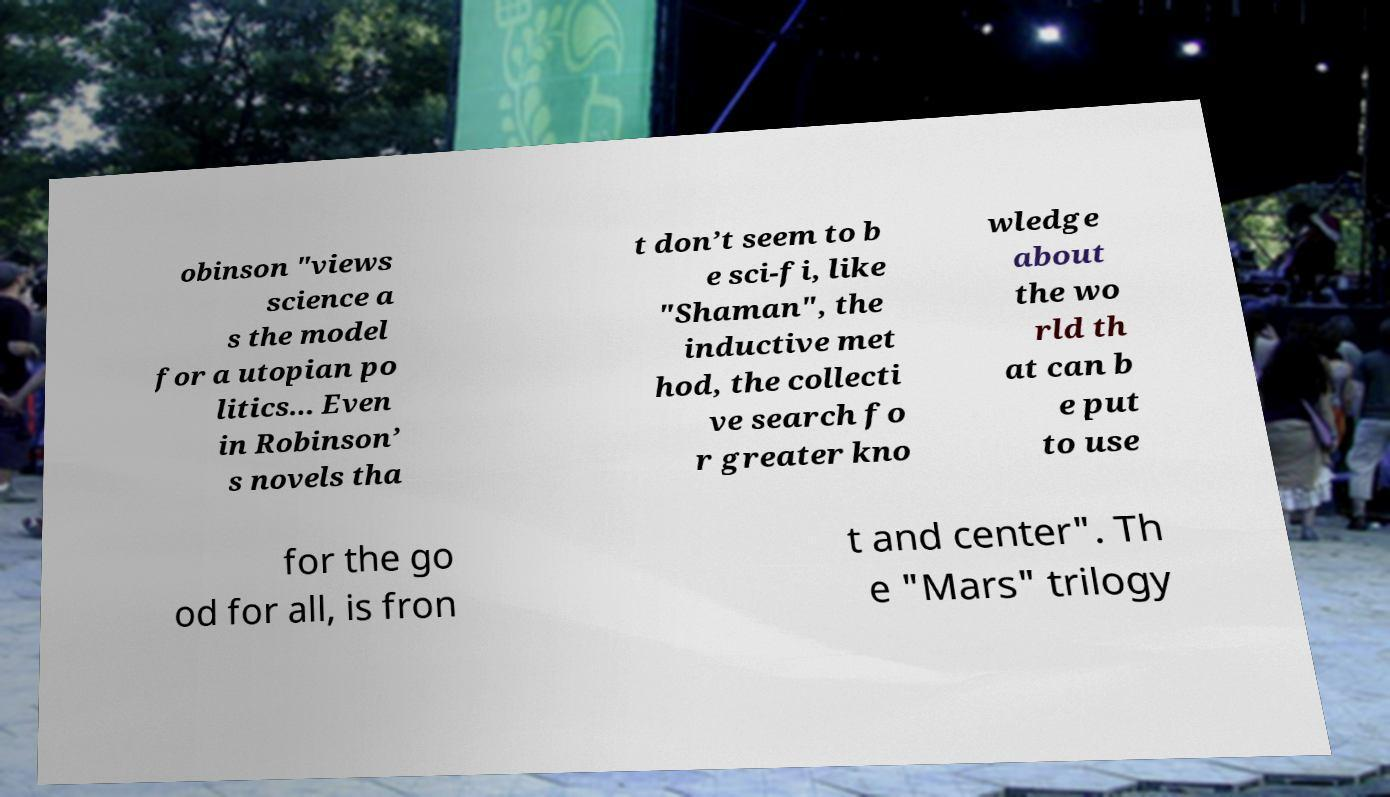Could you assist in decoding the text presented in this image and type it out clearly? obinson "views science a s the model for a utopian po litics... Even in Robinson’ s novels tha t don’t seem to b e sci-fi, like "Shaman", the inductive met hod, the collecti ve search fo r greater kno wledge about the wo rld th at can b e put to use for the go od for all, is fron t and center". Th e "Mars" trilogy 